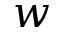Convert formula to latex. <formula><loc_0><loc_0><loc_500><loc_500>w</formula> 